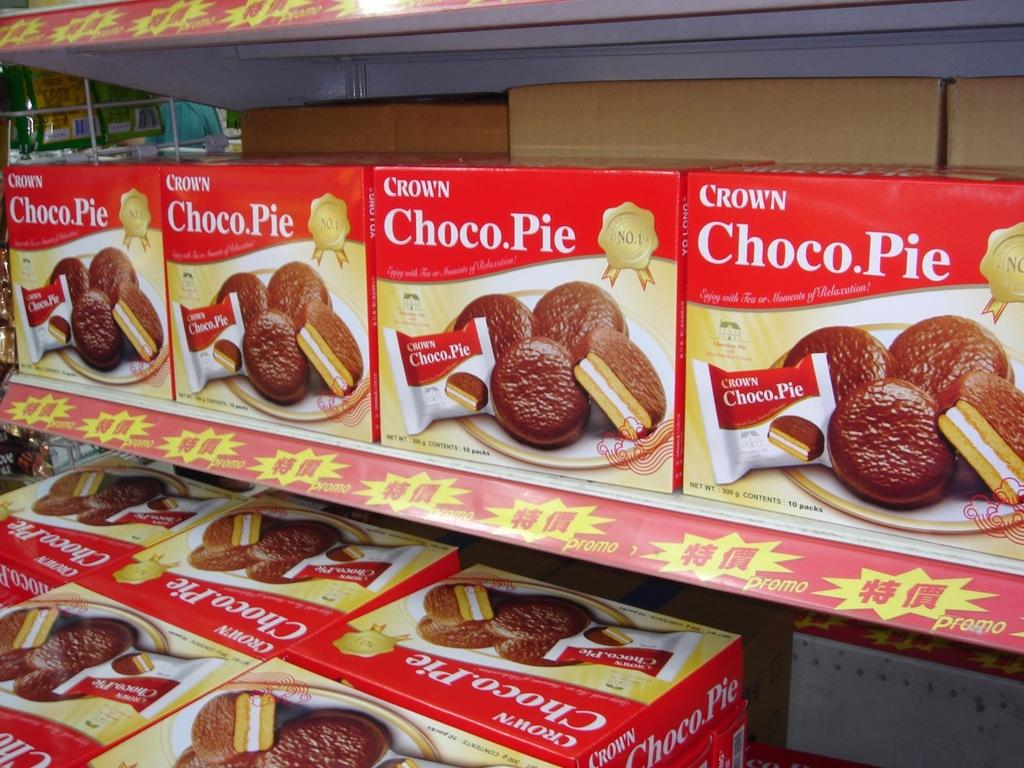What type of containers are visible in the image? There are carton boxes in the image. How are the carton boxes arranged? The carton boxes are in a rack. What food item is placed on the carton boxes? There are biscuits on a plate on the carton boxes. What can be seen near the wall in the top left corner of the image? There are objects near the wall in the top left corner of the image. Can you see the kitty's mouth in the image? There is no kitty present in the image, so its mouth cannot be seen. 